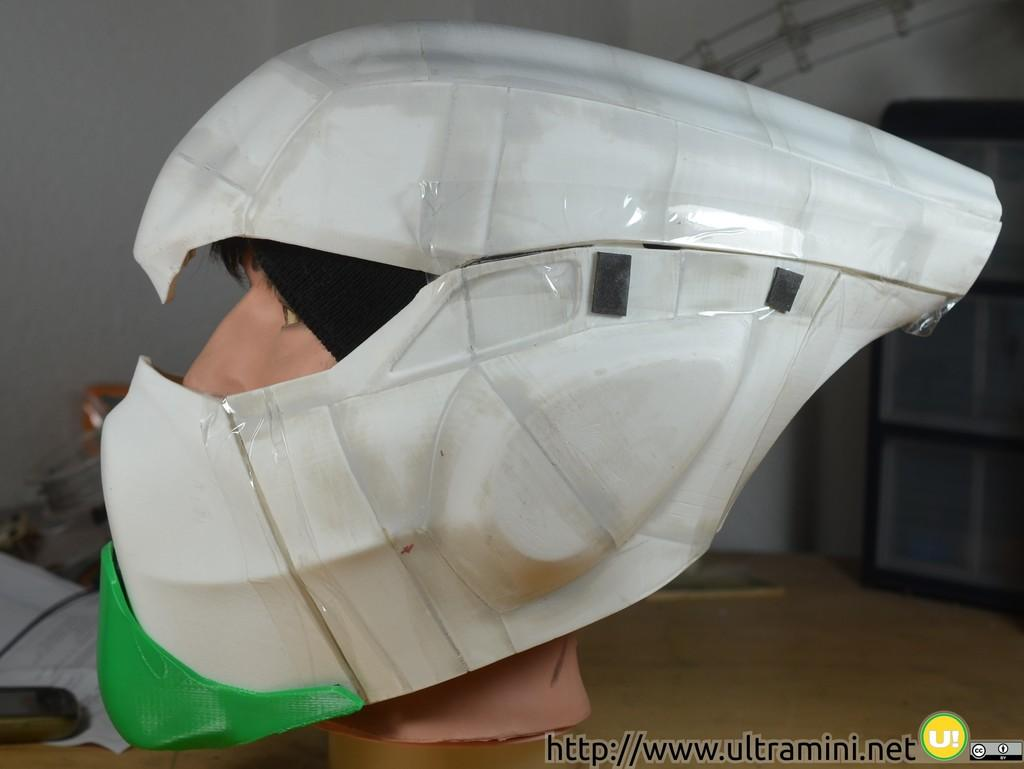What is the main subject of the image? The main subject of the image is a model of a human face. What is covering the model in the image? The model is under a helmet. What is the chance of finding a stone inside the helmet in the image? There is no mention of a stone in the image, so it is not possible to determine the chance of finding one inside the helmet. 